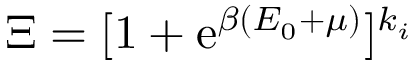<formula> <loc_0><loc_0><loc_500><loc_500>\Xi = [ 1 + e ^ { \beta ( E _ { 0 } + \mu ) } ] ^ { k _ { i } }</formula> 